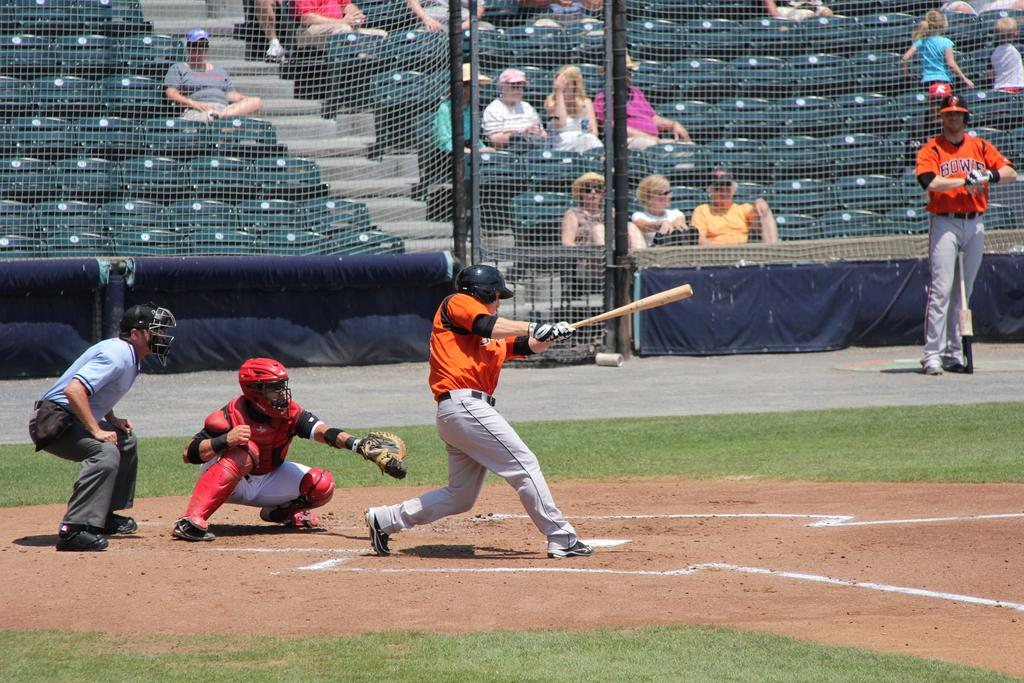<image>
Render a clear and concise summary of the photo. A baseball field showing a hitter about to bat with players wearing orange uniforms with the team name Bowie. 